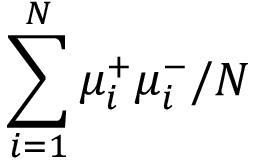Convert formula to latex. <formula><loc_0><loc_0><loc_500><loc_500>\sum _ { i = 1 } ^ { N } \mu _ { i } ^ { + } \mu _ { i } ^ { - } \slash N</formula> 